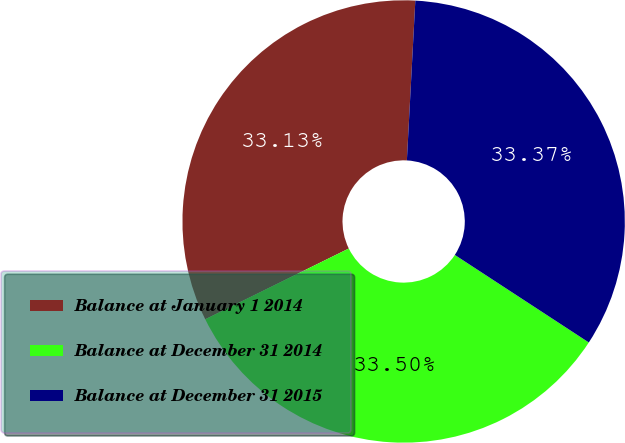<chart> <loc_0><loc_0><loc_500><loc_500><pie_chart><fcel>Balance at January 1 2014<fcel>Balance at December 31 2014<fcel>Balance at December 31 2015<nl><fcel>33.13%<fcel>33.5%<fcel>33.37%<nl></chart> 